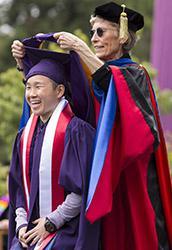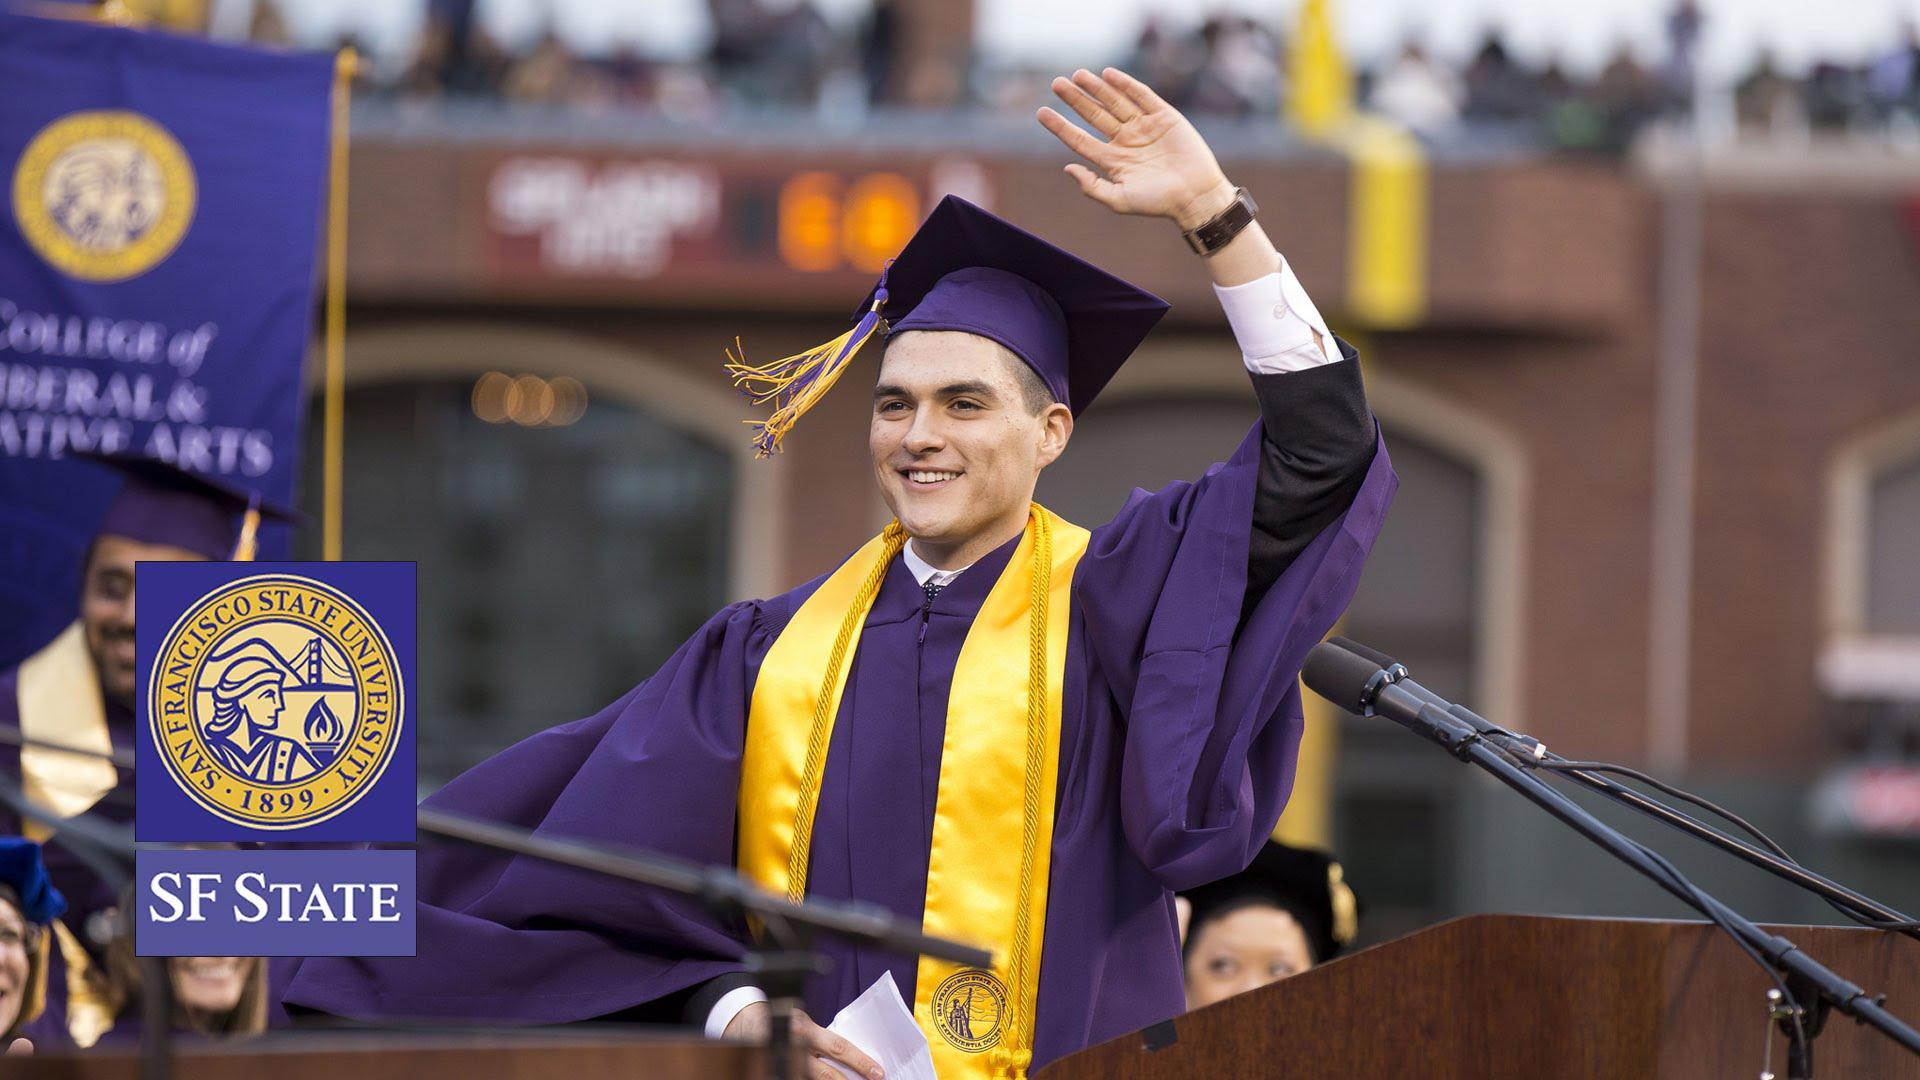The first image is the image on the left, the second image is the image on the right. For the images shown, is this caption "No more than two people in graduation robes can be seen in either picture." true? Answer yes or no. Yes. The first image is the image on the left, the second image is the image on the right. Analyze the images presented: Is the assertion "One image features a single graduate in the foreground raising at least one hand in the air, and wearing a royal purple robe with yellow around the neck and a hat with a tassle." valid? Answer yes or no. Yes. 